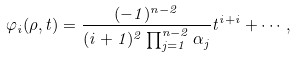Convert formula to latex. <formula><loc_0><loc_0><loc_500><loc_500>\varphi _ { i } ( \rho , t ) = \frac { ( - 1 ) ^ { n - 2 } } { ( i + 1 ) ^ { 2 } \prod _ { j = 1 } ^ { n - 2 } { \alpha _ { j } } } t ^ { i + i } + \cdots ,</formula> 